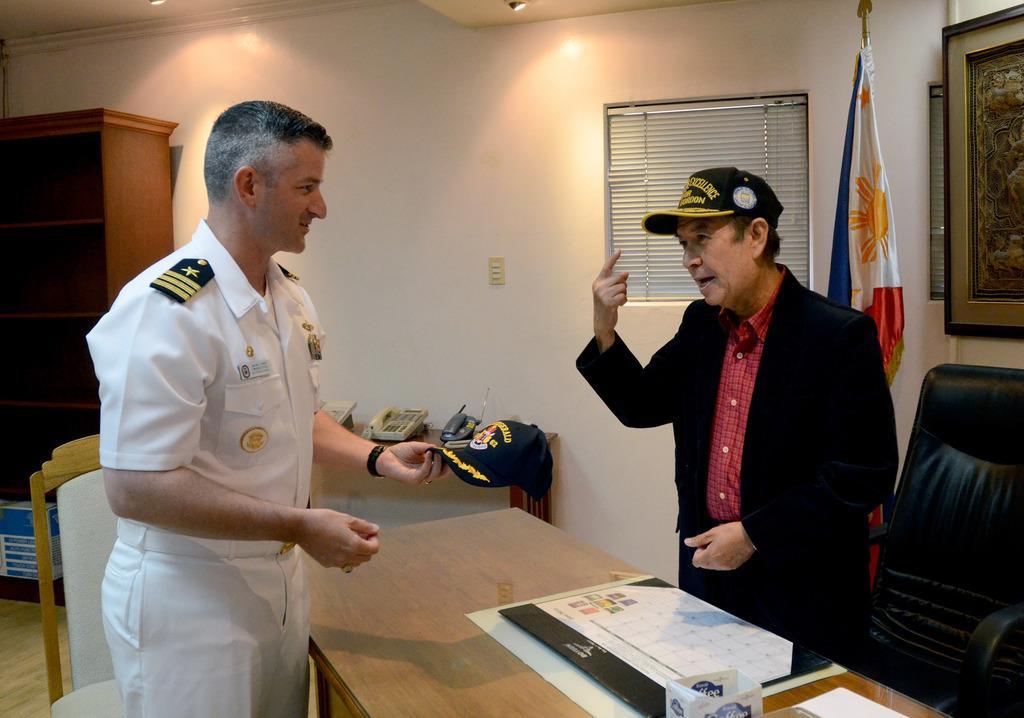Could you give a brief overview of what you see in this image? Here we can see two persons are standing, and in front here is the table and some objects on it ,and here is the flag, and here is the wall and photo frames on it. 